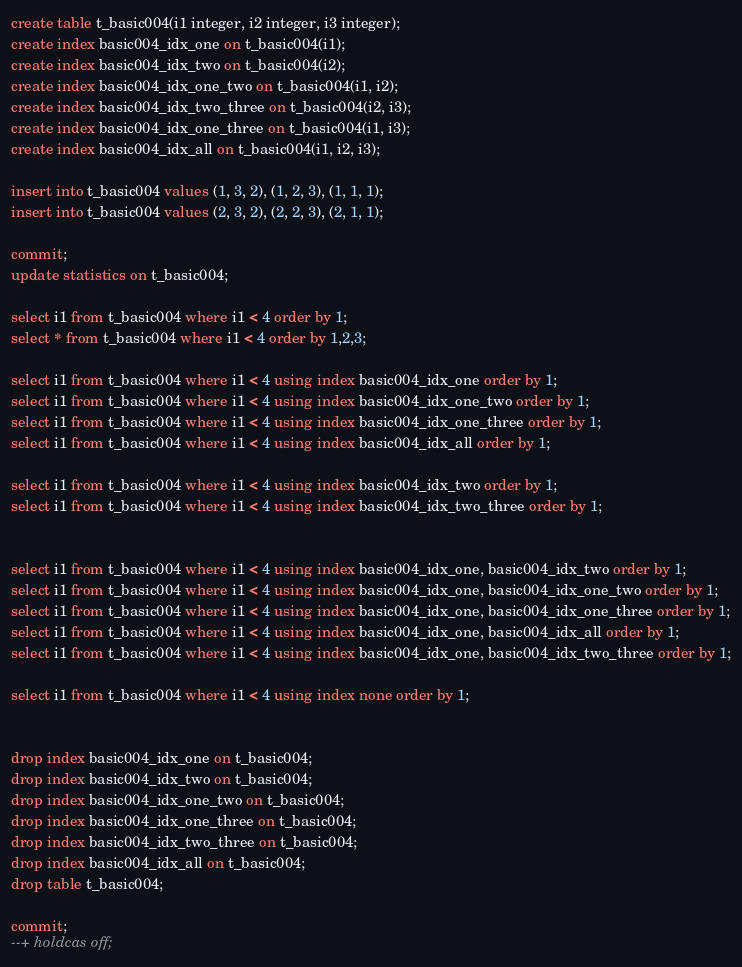Convert code to text. <code><loc_0><loc_0><loc_500><loc_500><_SQL_>create table t_basic004(i1 integer, i2 integer, i3 integer);
create index basic004_idx_one on t_basic004(i1);
create index basic004_idx_two on t_basic004(i2);
create index basic004_idx_one_two on t_basic004(i1, i2);
create index basic004_idx_two_three on t_basic004(i2, i3);
create index basic004_idx_one_three on t_basic004(i1, i3);
create index basic004_idx_all on t_basic004(i1, i2, i3);

insert into t_basic004 values (1, 3, 2), (1, 2, 3), (1, 1, 1);
insert into t_basic004 values (2, 3, 2), (2, 2, 3), (2, 1, 1);

commit;
update statistics on t_basic004;

select i1 from t_basic004 where i1 < 4 order by 1;
select * from t_basic004 where i1 < 4 order by 1,2,3;

select i1 from t_basic004 where i1 < 4 using index basic004_idx_one order by 1;
select i1 from t_basic004 where i1 < 4 using index basic004_idx_one_two order by 1;
select i1 from t_basic004 where i1 < 4 using index basic004_idx_one_three order by 1;
select i1 from t_basic004 where i1 < 4 using index basic004_idx_all order by 1;

select i1 from t_basic004 where i1 < 4 using index basic004_idx_two order by 1;
select i1 from t_basic004 where i1 < 4 using index basic004_idx_two_three order by 1;


select i1 from t_basic004 where i1 < 4 using index basic004_idx_one, basic004_idx_two order by 1;
select i1 from t_basic004 where i1 < 4 using index basic004_idx_one, basic004_idx_one_two order by 1;
select i1 from t_basic004 where i1 < 4 using index basic004_idx_one, basic004_idx_one_three order by 1;
select i1 from t_basic004 where i1 < 4 using index basic004_idx_one, basic004_idx_all order by 1;
select i1 from t_basic004 where i1 < 4 using index basic004_idx_one, basic004_idx_two_three order by 1;

select i1 from t_basic004 where i1 < 4 using index none order by 1;


drop index basic004_idx_one on t_basic004;
drop index basic004_idx_two on t_basic004;
drop index basic004_idx_one_two on t_basic004;
drop index basic004_idx_one_three on t_basic004;
drop index basic004_idx_two_three on t_basic004;
drop index basic004_idx_all on t_basic004;
drop table t_basic004;

commit;
--+ holdcas off;
</code> 